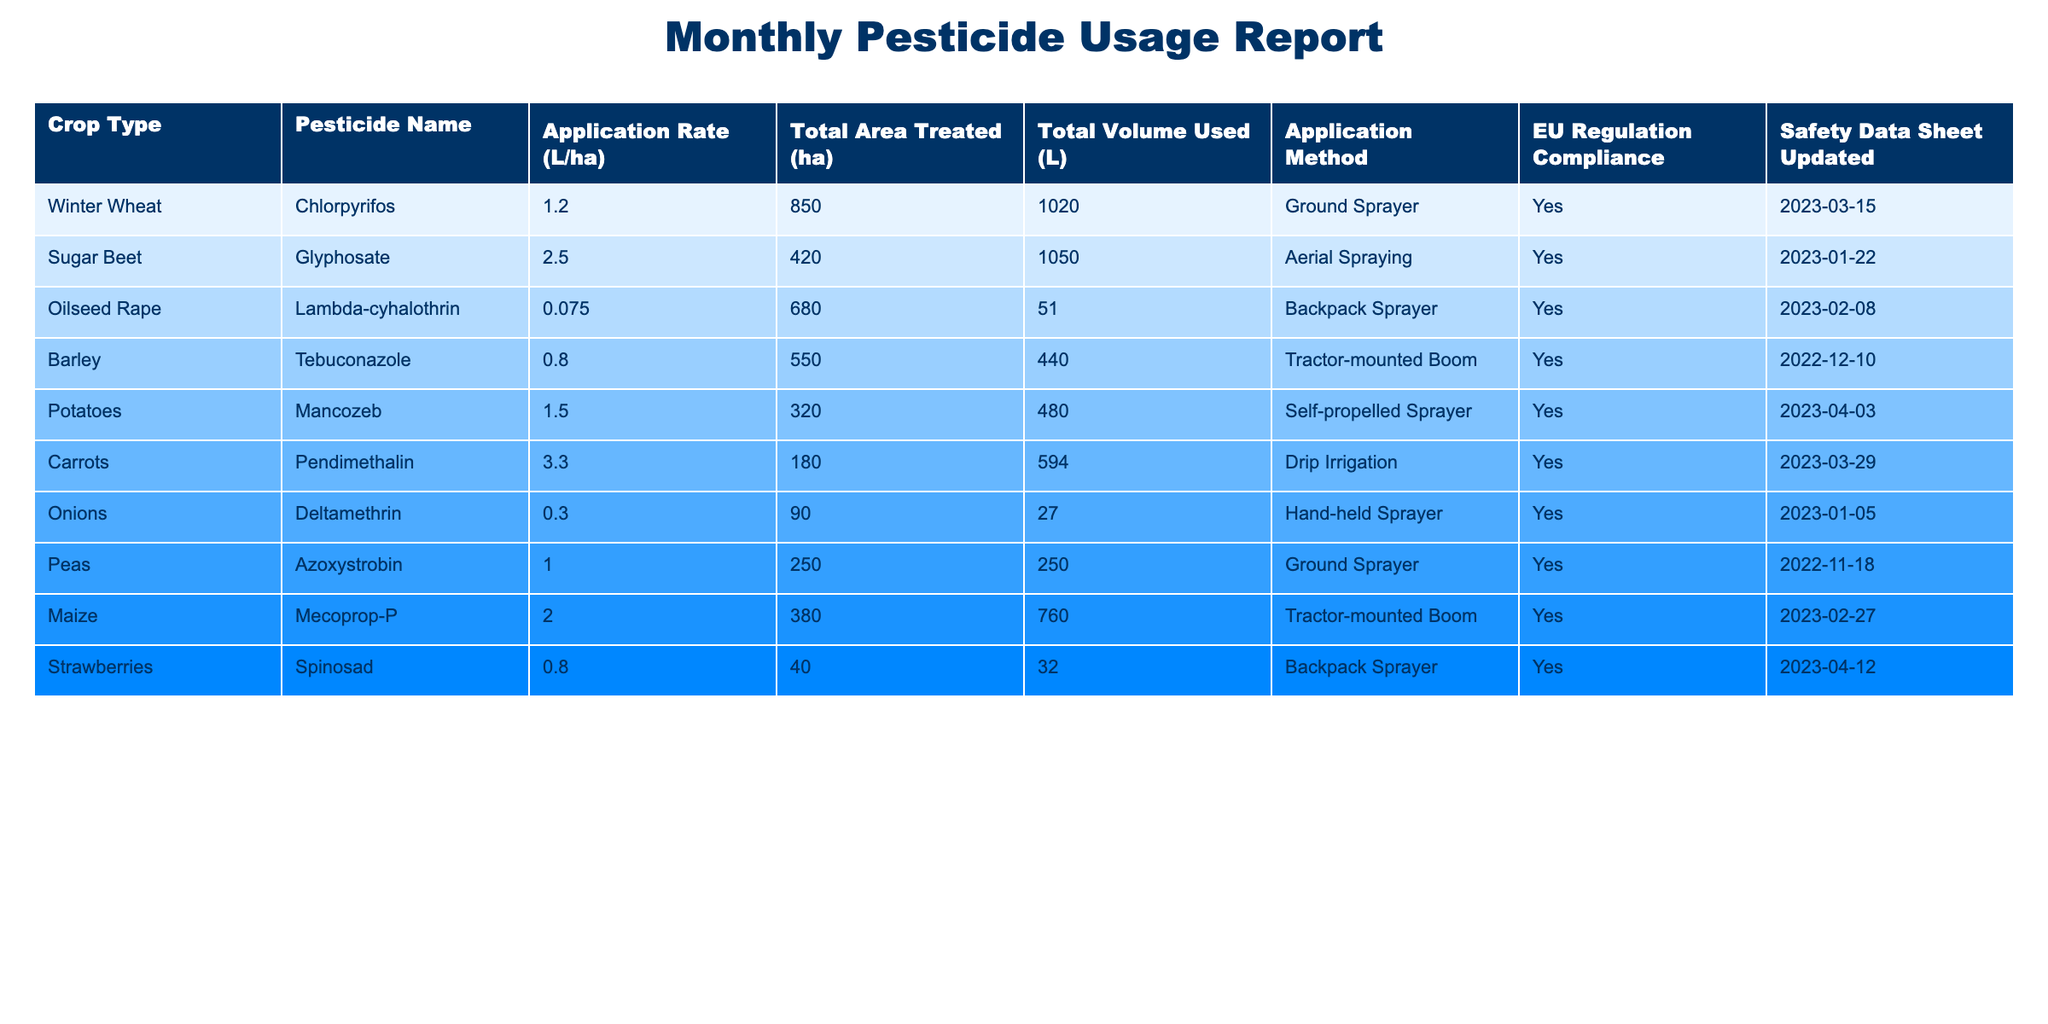What is the total volume of Glyphosate used? According to the table, the total volume of Glyphosate used for Sugar Beet is 1050 liters.
Answer: 1050 liters Which crop type had the highest application rate? Looking at the 'Application Rate (L/ha)' column, Pendimethalin for Carrots has the highest rate at 3.3 L/ha.
Answer: Carrots How many crop types used a ground sprayer? The table indicates that 4 crop types (Winter Wheat, Peas, Maize, and Potatoes) used a ground sprayer as the application method.
Answer: 4 Is the Safety Data Sheet for Deltamethrin updated? The 'Safety Data Sheet Updated' column shows that it was last updated on 2023-01-05, indicating that it is indeed updated.
Answer: Yes What is the total area treated for all crops combined? To find the total area treated, we sum all values in the 'Total Area Treated (ha)' column: 850 + 420 + 680 + 550 + 320 + 180 + 90 + 250 + 380 + 40 = 3560 ha.
Answer: 3560 ha Which pesticide had the lowest total volume used? By comparing the 'Total Volume Used (L)' column, we see Deltamethrin had the lowest total volume at 27 liters.
Answer: Deltamethrin How many pesticides are compliant with EU regulations? Reviewing the 'EU Regulation Compliance' column, all 10 crop types listed are marked as 'Yes', indicating they comply.
Answer: 10 What is the average application rate for the crops that used tractor-mounted boom? The application rates for crops using tractor-mounted boom are 0.8 (Barley) and 2.0 (Maize). The average is calculated as (0.8 + 2.0) / 2 = 1.4 L/ha.
Answer: 1.4 L/ha Which crop type had the highest total volume used, and what was that volume? Looking through the 'Total Volume Used (L)' column, the highest total volume is 1050 liters for Glyphosate used on Sugar Beet.
Answer: Sugar Beet, 1050 liters Was any pesticide used with a total area treated of less than 100 hectares? The 'Total Area Treated (ha)' column shows that only Strawberries had an area treated of 40 hectares, confirming this fact.
Answer: Yes 